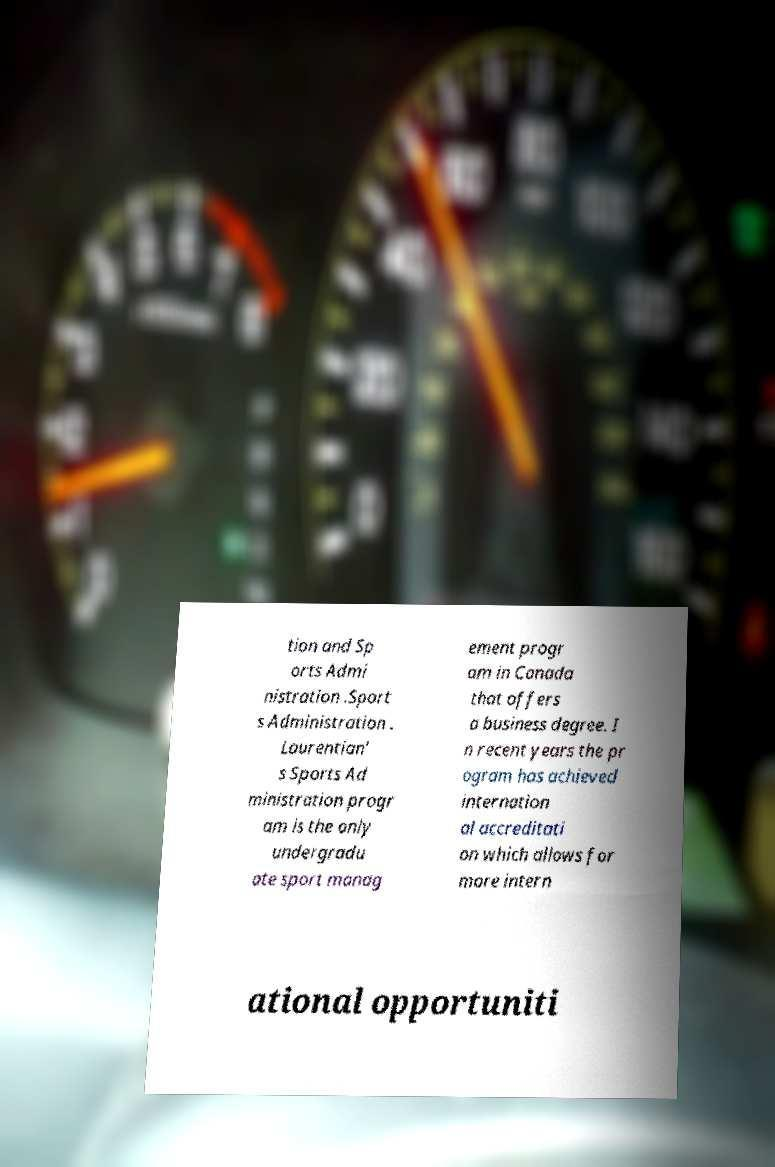Could you assist in decoding the text presented in this image and type it out clearly? tion and Sp orts Admi nistration .Sport s Administration . Laurentian' s Sports Ad ministration progr am is the only undergradu ate sport manag ement progr am in Canada that offers a business degree. I n recent years the pr ogram has achieved internation al accreditati on which allows for more intern ational opportuniti 